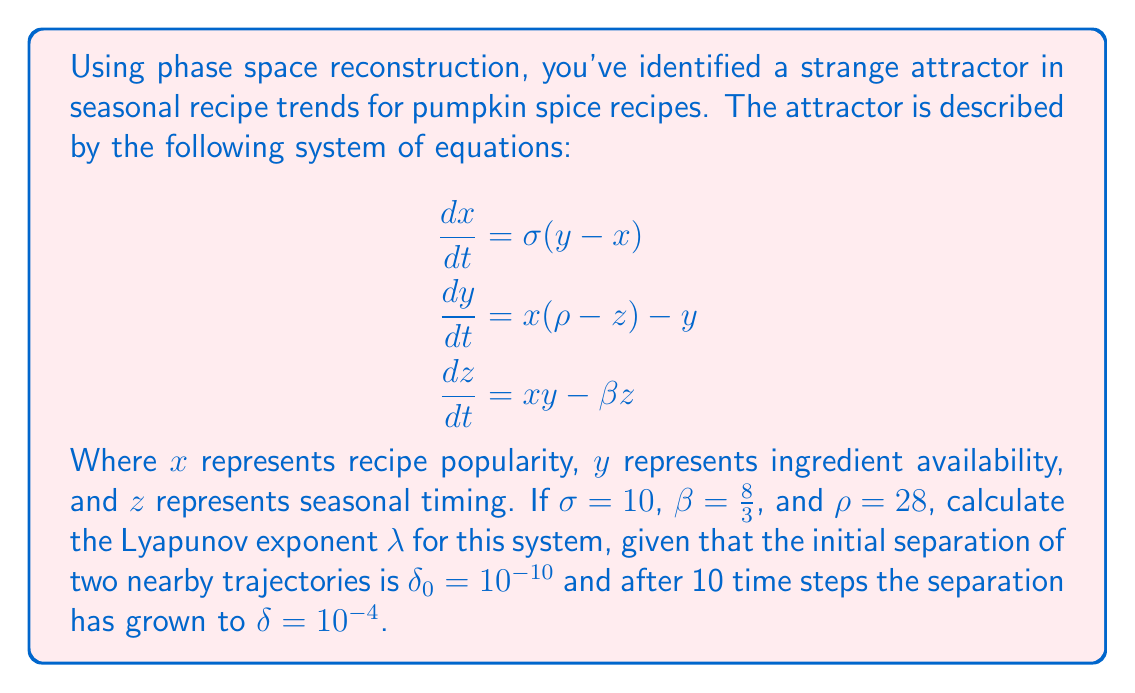Solve this math problem. To solve this problem, we'll follow these steps:

1) The Lyapunov exponent $\lambda$ measures the rate of separation of infinitesimally close trajectories. It's defined by the equation:

   $$\lambda = \lim_{t \to \infty} \lim_{\delta_0 \to 0} \frac{1}{t} \ln \frac{\|\delta(t)\|}{\|\delta_0\|}$$

2) In our case, we don't have infinite time, but we can approximate $\lambda$ using the given information:
   - Initial separation: $\delta_0 = 10^{-10}$
   - Final separation after 10 time steps: $\delta = 10^{-4}$
   - Time: $t = 10$

3) Plugging these values into the Lyapunov exponent formula:

   $$\lambda \approx \frac{1}{t} \ln \frac{\|\delta\|}{\|\delta_0\|}$$

4) Substituting the values:

   $$\lambda \approx \frac{1}{10} \ln \frac{10^{-4}}{10^{-10}}$$

5) Simplify inside the logarithm:

   $$\lambda \approx \frac{1}{10} \ln (10^6)$$

6) Use the logarithm property $\ln(10^n) = n\ln(10)$:

   $$\lambda \approx \frac{1}{10} (6 \ln 10)$$

7) Calculate:

   $$\lambda \approx 0.6 \ln 10 \approx 1.38$$

This positive Lyapunov exponent indicates chaotic behavior in the pumpkin spice recipe trend system, suggesting that small changes in initial conditions can lead to significantly different outcomes over time.
Answer: $\lambda \approx 1.38$ 